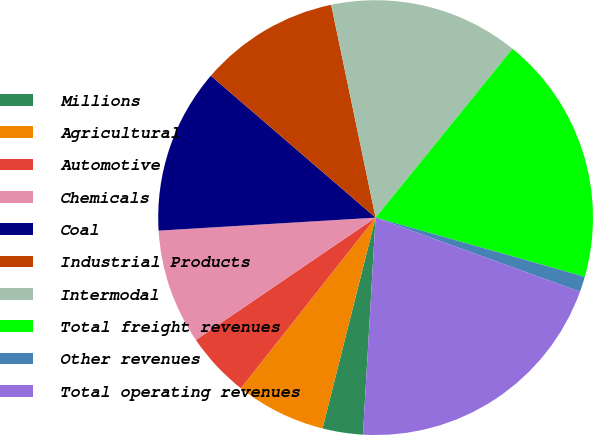<chart> <loc_0><loc_0><loc_500><loc_500><pie_chart><fcel>Millions<fcel>Agricultural<fcel>Automotive<fcel>Chemicals<fcel>Coal<fcel>Industrial Products<fcel>Intermodal<fcel>Total freight revenues<fcel>Other revenues<fcel>Total operating revenues<nl><fcel>3.0%<fcel>6.71%<fcel>4.85%<fcel>8.56%<fcel>12.27%<fcel>10.41%<fcel>14.12%<fcel>18.54%<fcel>1.15%<fcel>20.39%<nl></chart> 